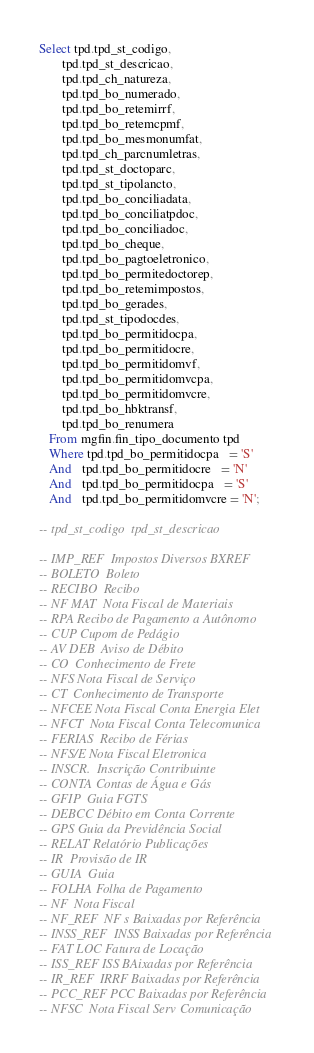<code> <loc_0><loc_0><loc_500><loc_500><_SQL_>Select tpd.tpd_st_codigo,         
       tpd.tpd_st_descricao,      
       tpd.tpd_ch_natureza,      
       tpd.tpd_bo_numerado,       
       tpd.tpd_bo_retemirrf,      
       tpd.tpd_bo_retemcpmf,     
       tpd.tpd_bo_mesmonumfat,    
       tpd.tpd_ch_parcnumletras,  
       tpd.tpd_st_doctoparc,      
       tpd.tpd_st_tipolancto,     
       tpd.tpd_bo_conciliadata,   
       tpd.tpd_bo_conciliatpdoc,  
       tpd.tpd_bo_conciliadoc,    
       tpd.tpd_bo_cheque,         
       tpd.tpd_bo_pagtoeletronico,
       tpd.tpd_bo_permitedoctorep,
       tpd.tpd_bo_retemimpostos,  
       tpd.tpd_bo_gerades,        
       tpd.tpd_st_tipodocdes,     
       tpd.tpd_bo_permitidocpa,   
       tpd.tpd_bo_permitidocre,   
       tpd.tpd_bo_permitidomvf,   
       tpd.tpd_bo_permitidomvcpa, 
       tpd.tpd_bo_permitidomvcre, 
       tpd.tpd_bo_hbktransf,      
       tpd.tpd_bo_renumera       
   From mgfin.fin_tipo_documento tpd
   Where tpd.tpd_bo_permitidocpa   = 'S'
   And   tpd.tpd_bo_permitidocre   = 'N'
   And   tpd.tpd_bo_permitidocpa   = 'S'
   And   tpd.tpd_bo_permitidomvcre = 'N';

-- tpd_st_codigo  tpd_st_descricao

-- IMP_REF  Impostos Diversos BXREF
-- BOLETO  Boleto
-- RECIBO  Recibo
-- NF MAT  Nota Fiscal de Materiais
-- RPA Recibo de Pagamento a Autônomo
-- CUP Cupom de Pedágio
-- AV DEB  Aviso de Débito
-- CO  Conhecimento de Frete
-- NFS Nota Fiscal de Serviço
-- CT  Conhecimento de Transporte
-- NFCEE Nota Fiscal Conta Energia Elet
-- NFCT  Nota Fiscal Conta Telecomunica
-- FERIAS  Recibo de Férias
-- NFS/E Nota Fiscal Eletronica
-- INSCR.  Inscrição Contribuinte
-- CONTA Contas de Água e Gás
-- GFIP  Guia FGTS
-- DEBCC Débito em Conta Corrente
-- GPS Guia da Previdência Social
-- RELAT Relatório Publicações
-- IR  Provisão de IR
-- GUIA  Guia
-- FOLHA Folha de Pagamento
-- NF  Nota Fiscal
-- NF_REF  NF s Baixadas por Referência
-- INSS_REF  INSS Baixadas por Referência
-- FAT LOC Fatura de Locação
-- ISS_REF ISS BAixadas por Referência
-- IR_REF  IRRF Baixadas por Referência
-- PCC_REF PCC Baixadas por Referência
-- NFSC  Nota Fiscal Serv Comunicação</code> 